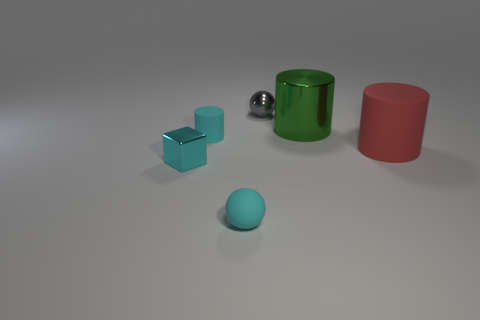Subtract all red rubber cylinders. How many cylinders are left? 2 Add 1 big matte objects. How many objects exist? 7 Subtract all cubes. How many objects are left? 5 Subtract all cyan cylinders. How many cylinders are left? 2 Subtract 2 cylinders. How many cylinders are left? 1 Add 6 matte cylinders. How many matte cylinders exist? 8 Subtract 0 green spheres. How many objects are left? 6 Subtract all brown cylinders. Subtract all cyan balls. How many cylinders are left? 3 Subtract all big yellow objects. Subtract all green cylinders. How many objects are left? 5 Add 1 small cyan blocks. How many small cyan blocks are left? 2 